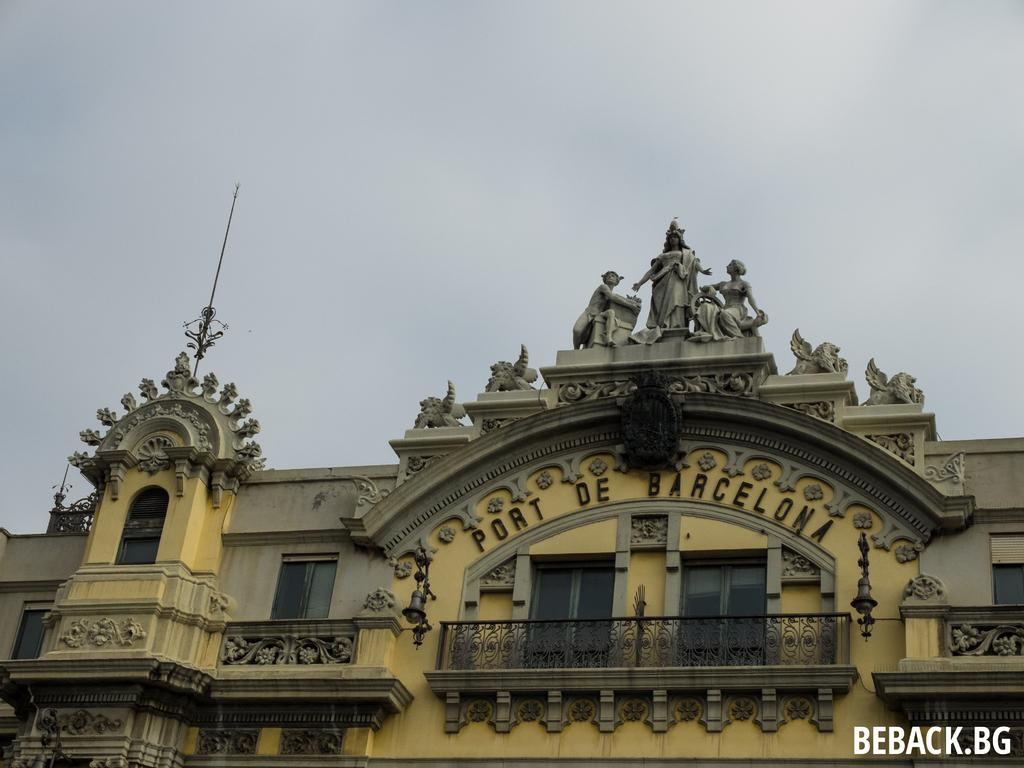<image>
Render a clear and concise summary of the photo. Large yellow building with Port De Barcelona on the front. 